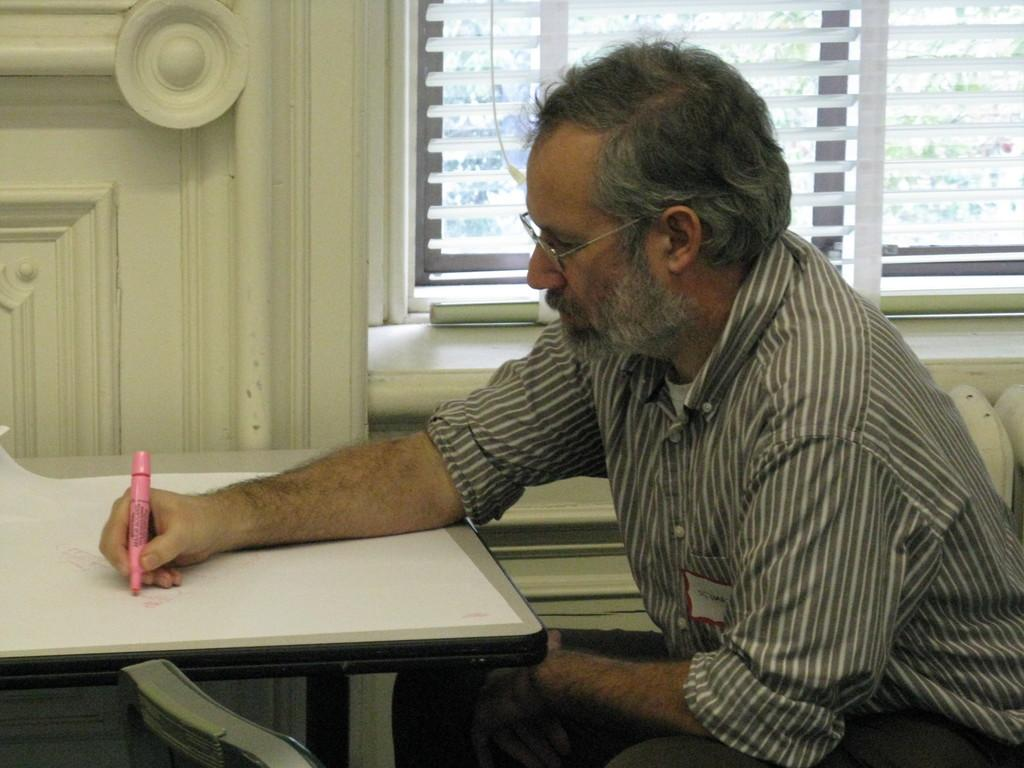What is the man in the image doing? The man is drawing on a paper. What is the man holding in the image? The man is holding a marker. What is the man wearing that helps him see better? The man is wearing glasses (specs). What is in front of the man while he is drawing? There is a table in front of the man. What can be seen in the background of the image? There is a wooden wall and a window in the background. What type of brass instrument is the man playing in the image? There is no brass instrument present in the image; the man is drawing on a paper with a marker. What type of yam is the man using to draw on the paper? There is no yam present in the image; the man is using a marker to draw on the paper. 